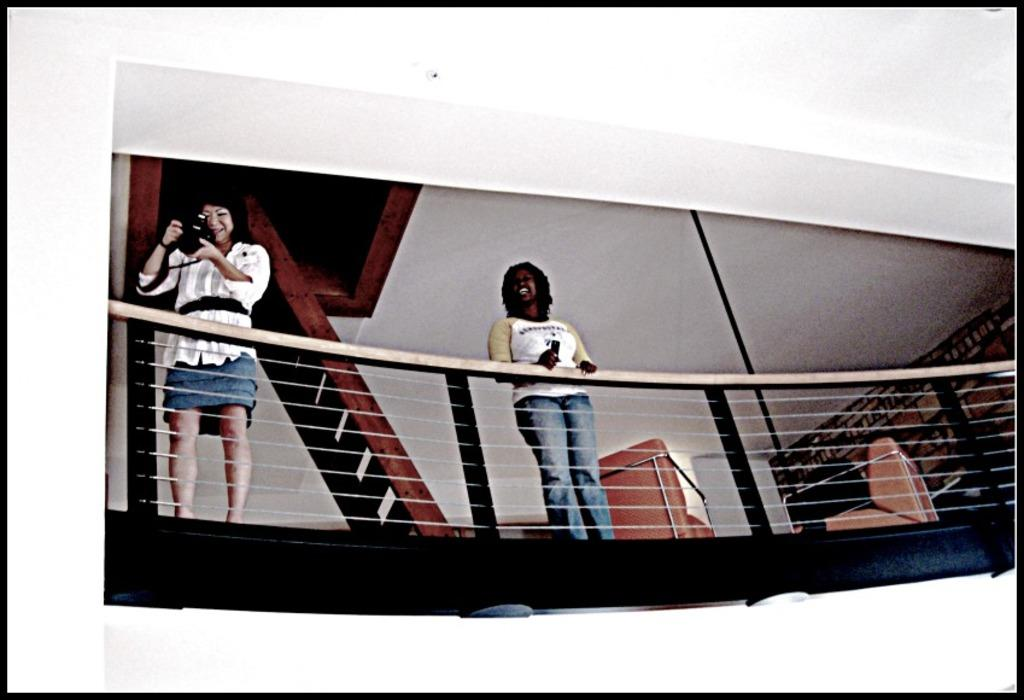What are the two people in the image doing? The two people are standing on a building. What safety feature is visible in the image? There is a railing visible in the image. What can be seen in the background of the image? There is a shelf and a wall in the background of the image. What grade did the people in the image receive for their story? There is no story or grade mentioned in the image; it only shows two people standing on a building. 